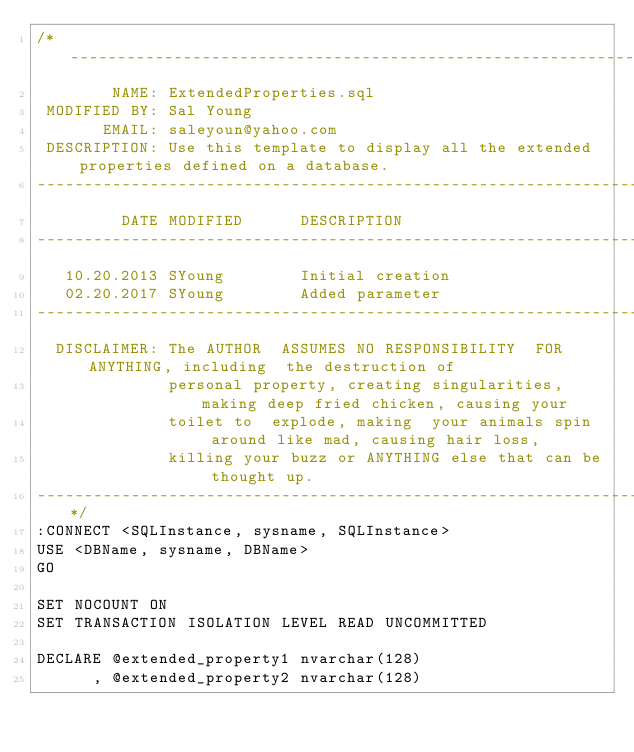<code> <loc_0><loc_0><loc_500><loc_500><_SQL_>/*-----------------------------------------------------------------------------------------------
        NAME: ExtendedProperties.sql
 MODIFIED BY: Sal Young
       EMAIL: saleyoun@yahoo.com
 DESCRIPTION: Use this template to display all the extended properties defined on a database.
-------------------------------------------------------------------------------------------------
         DATE MODIFIED      DESCRIPTION    
-------------------------------------------------------------------------------------------------
   10.20.2013 SYoung        Initial creation
   02.20.2017 SYoung        Added parameter
-------------------------------------------------------------------------------------------------
  DISCLAIMER: The AUTHOR  ASSUMES NO RESPONSIBILITY  FOR ANYTHING, including  the destruction of
              personal property, creating singularities, making deep fried chicken, causing your
              toilet to  explode, making  your animals spin  around like mad, causing hair loss,
              killing your buzz or ANYTHING else that can be thought up.
-----------------------------------------------------------------------------------------------*/
:CONNECT <SQLInstance, sysname, SQLInstance>
USE <DBName, sysname, DBName>
GO
 
SET NOCOUNT ON
SET TRANSACTION ISOLATION LEVEL READ UNCOMMITTED
 
DECLARE @extended_property1 nvarchar(128)
      , @extended_property2 nvarchar(128)
 </code> 